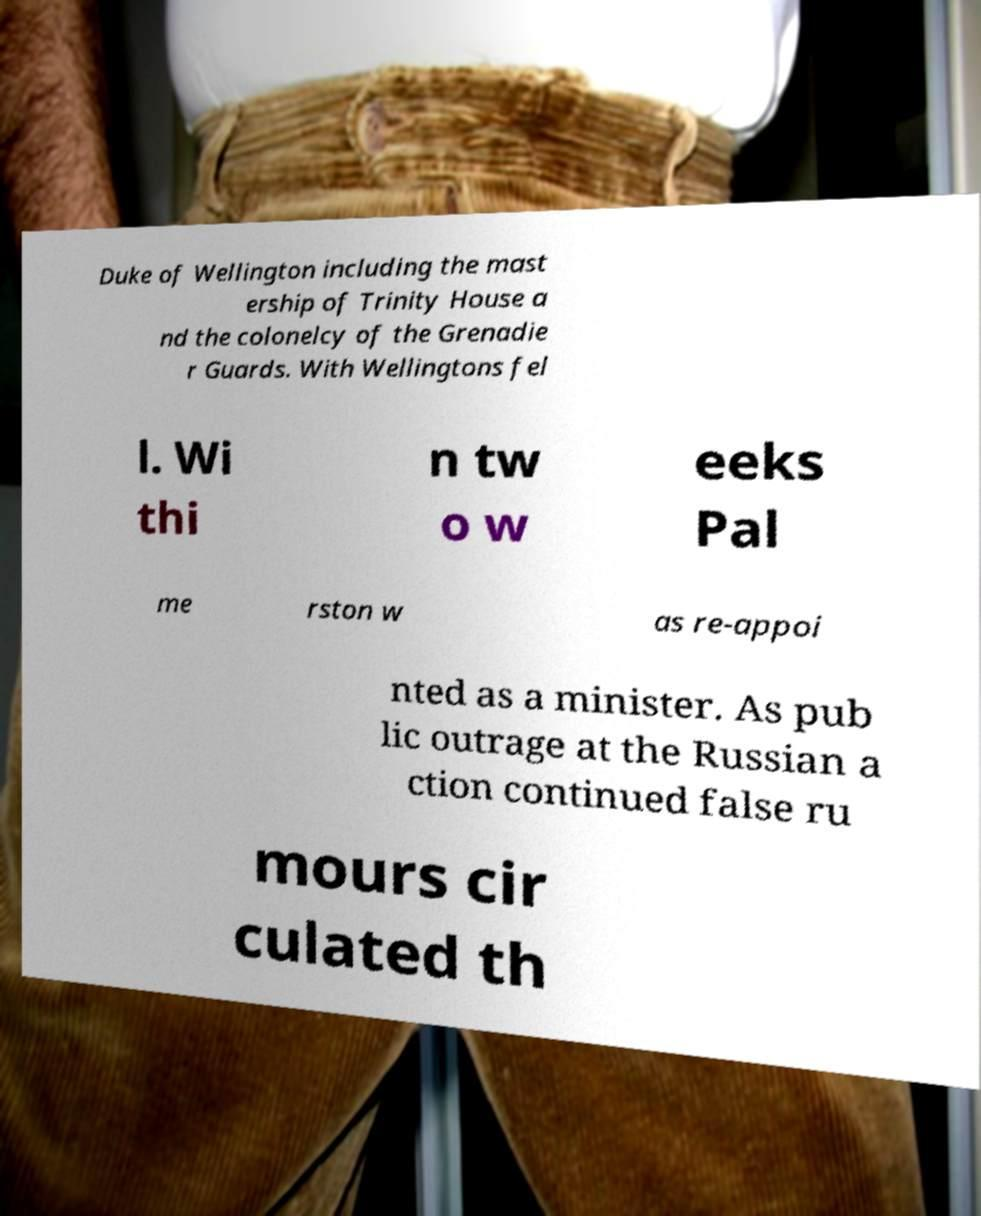What messages or text are displayed in this image? I need them in a readable, typed format. Duke of Wellington including the mast ership of Trinity House a nd the colonelcy of the Grenadie r Guards. With Wellingtons fel l. Wi thi n tw o w eeks Pal me rston w as re-appoi nted as a minister. As pub lic outrage at the Russian a ction continued false ru mours cir culated th 